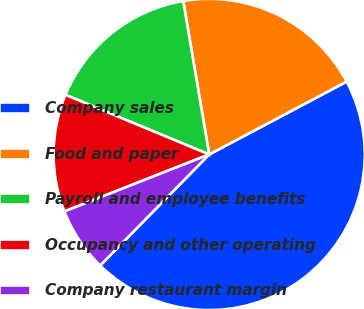<chart> <loc_0><loc_0><loc_500><loc_500><pie_chart><fcel>Company sales<fcel>Food and paper<fcel>Payroll and employee benefits<fcel>Occupancy and other operating<fcel>Company restaurant margin<nl><fcel>45.11%<fcel>19.91%<fcel>16.07%<fcel>12.23%<fcel>6.68%<nl></chart> 